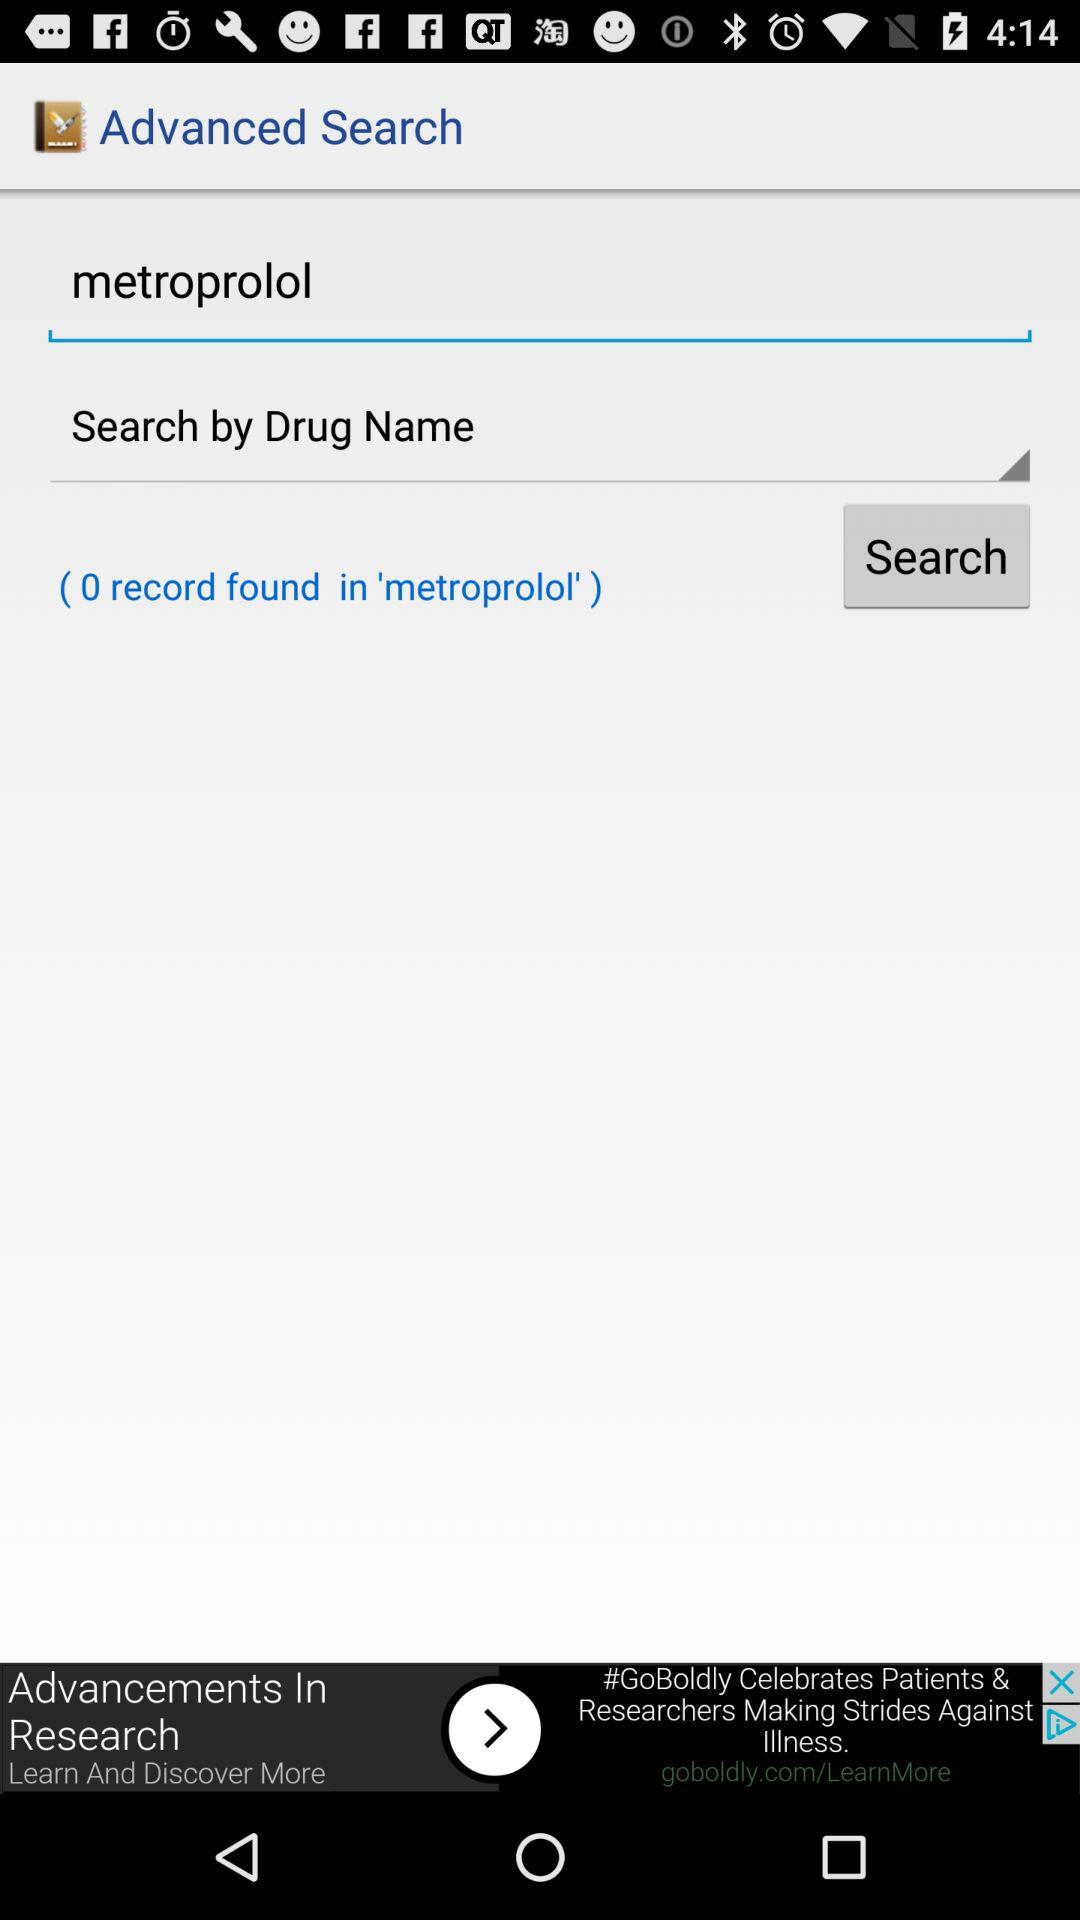What word is being searched? The word is "metroprolol". 